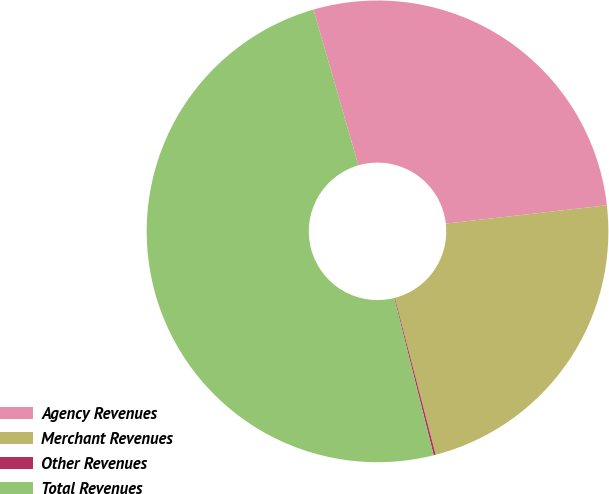Convert chart. <chart><loc_0><loc_0><loc_500><loc_500><pie_chart><fcel>Agency Revenues<fcel>Merchant Revenues<fcel>Other Revenues<fcel>Total Revenues<nl><fcel>27.68%<fcel>22.75%<fcel>0.14%<fcel>49.44%<nl></chart> 